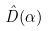Convert formula to latex. <formula><loc_0><loc_0><loc_500><loc_500>\hat { D } ( \alpha )</formula> 